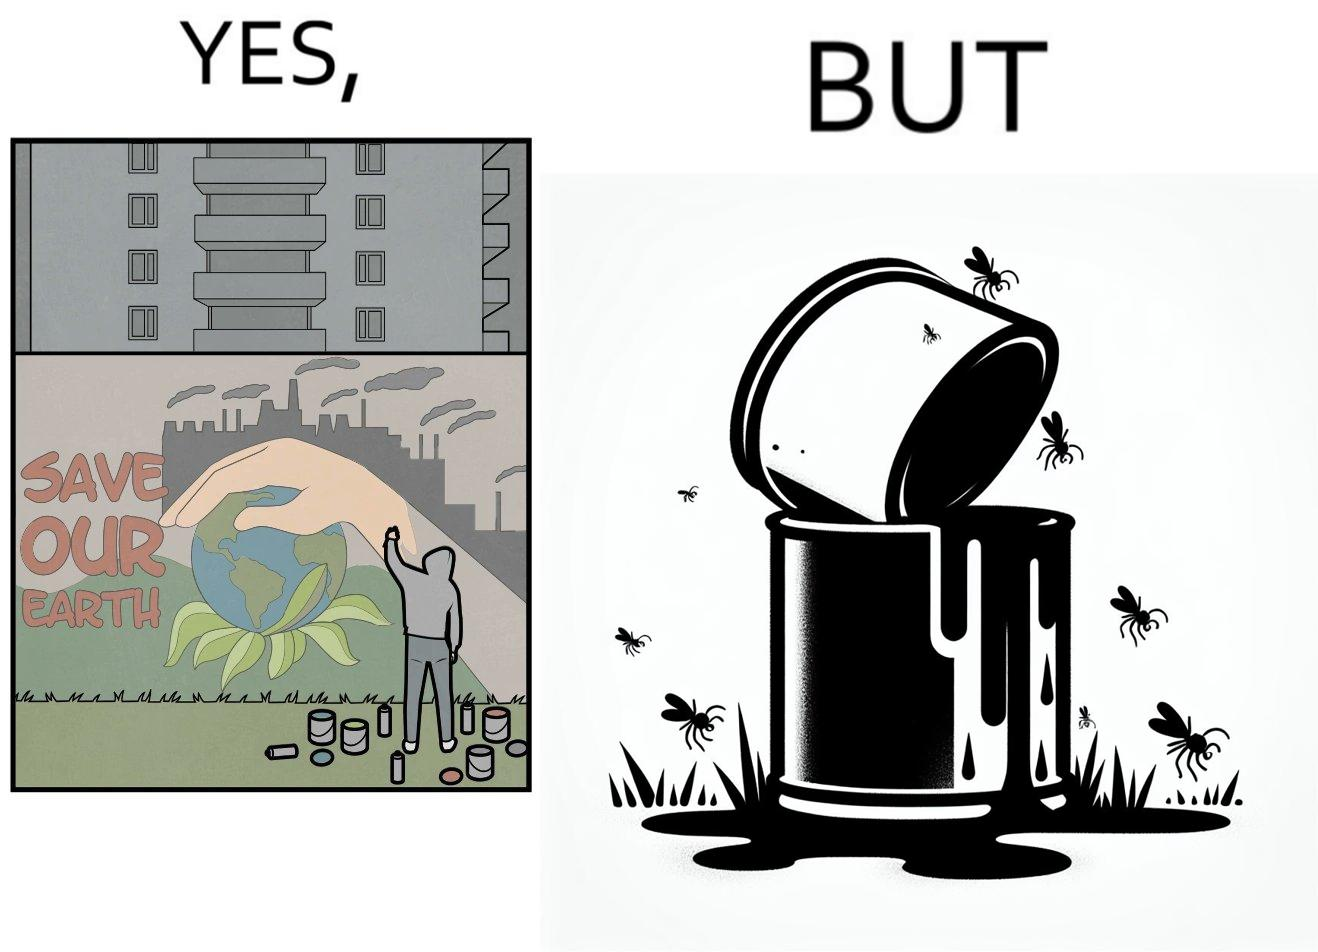Does this image contain satire or humor? Yes, this image is satirical. 